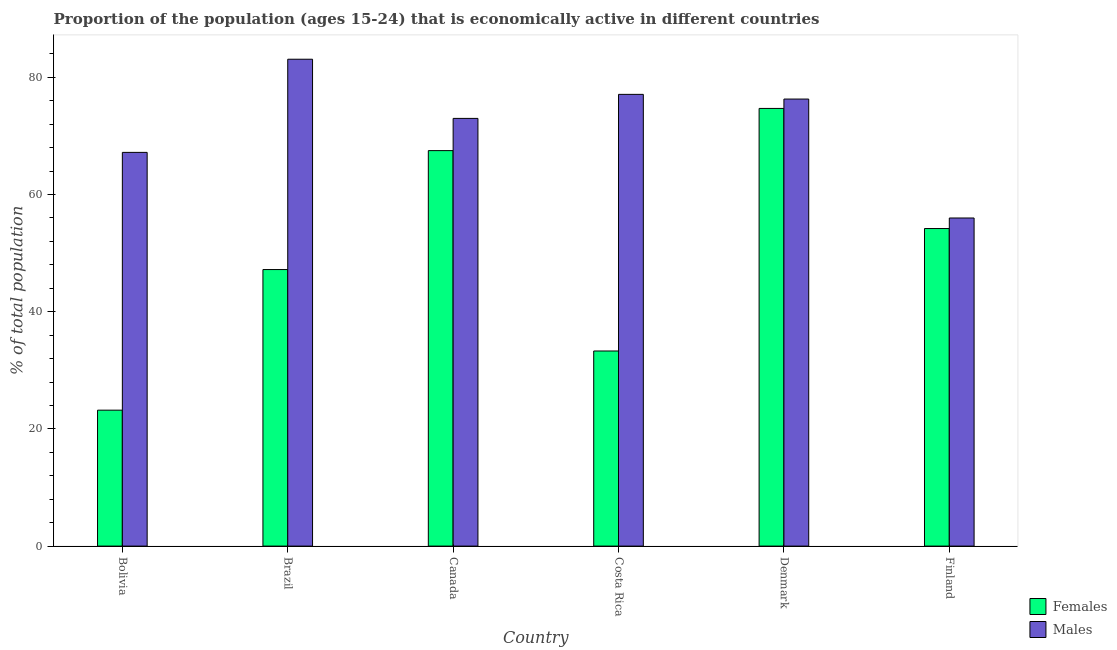How many different coloured bars are there?
Provide a succinct answer. 2. Are the number of bars on each tick of the X-axis equal?
Your response must be concise. Yes. How many bars are there on the 6th tick from the left?
Make the answer very short. 2. How many bars are there on the 3rd tick from the right?
Your answer should be very brief. 2. What is the label of the 1st group of bars from the left?
Give a very brief answer. Bolivia. What is the percentage of economically active male population in Brazil?
Make the answer very short. 83.1. Across all countries, what is the maximum percentage of economically active male population?
Give a very brief answer. 83.1. Across all countries, what is the minimum percentage of economically active female population?
Offer a terse response. 23.2. In which country was the percentage of economically active female population maximum?
Your answer should be compact. Denmark. What is the total percentage of economically active male population in the graph?
Your response must be concise. 432.7. What is the difference between the percentage of economically active female population in Canada and that in Finland?
Your answer should be compact. 13.3. What is the difference between the percentage of economically active female population in Canada and the percentage of economically active male population in Brazil?
Offer a very short reply. -15.6. What is the average percentage of economically active female population per country?
Your answer should be compact. 50.02. What is the ratio of the percentage of economically active male population in Bolivia to that in Costa Rica?
Keep it short and to the point. 0.87. Is the percentage of economically active male population in Brazil less than that in Finland?
Ensure brevity in your answer.  No. What is the difference between the highest and the second highest percentage of economically active male population?
Ensure brevity in your answer.  6. What is the difference between the highest and the lowest percentage of economically active female population?
Your answer should be compact. 51.5. In how many countries, is the percentage of economically active female population greater than the average percentage of economically active female population taken over all countries?
Provide a succinct answer. 3. Is the sum of the percentage of economically active female population in Bolivia and Canada greater than the maximum percentage of economically active male population across all countries?
Make the answer very short. Yes. What does the 1st bar from the left in Costa Rica represents?
Provide a short and direct response. Females. What does the 2nd bar from the right in Brazil represents?
Ensure brevity in your answer.  Females. Are all the bars in the graph horizontal?
Provide a succinct answer. No. How many countries are there in the graph?
Make the answer very short. 6. Does the graph contain any zero values?
Offer a very short reply. No. Does the graph contain grids?
Ensure brevity in your answer.  No. Where does the legend appear in the graph?
Give a very brief answer. Bottom right. What is the title of the graph?
Provide a succinct answer. Proportion of the population (ages 15-24) that is economically active in different countries. Does "Depositors" appear as one of the legend labels in the graph?
Provide a short and direct response. No. What is the label or title of the X-axis?
Keep it short and to the point. Country. What is the label or title of the Y-axis?
Provide a short and direct response. % of total population. What is the % of total population of Females in Bolivia?
Keep it short and to the point. 23.2. What is the % of total population of Males in Bolivia?
Ensure brevity in your answer.  67.2. What is the % of total population in Females in Brazil?
Offer a terse response. 47.2. What is the % of total population of Males in Brazil?
Your answer should be compact. 83.1. What is the % of total population of Females in Canada?
Make the answer very short. 67.5. What is the % of total population in Males in Canada?
Give a very brief answer. 73. What is the % of total population of Females in Costa Rica?
Ensure brevity in your answer.  33.3. What is the % of total population in Males in Costa Rica?
Give a very brief answer. 77.1. What is the % of total population in Females in Denmark?
Provide a short and direct response. 74.7. What is the % of total population of Males in Denmark?
Provide a short and direct response. 76.3. What is the % of total population of Females in Finland?
Your response must be concise. 54.2. What is the % of total population in Males in Finland?
Offer a terse response. 56. Across all countries, what is the maximum % of total population of Females?
Keep it short and to the point. 74.7. Across all countries, what is the maximum % of total population in Males?
Provide a succinct answer. 83.1. Across all countries, what is the minimum % of total population of Females?
Provide a short and direct response. 23.2. What is the total % of total population in Females in the graph?
Keep it short and to the point. 300.1. What is the total % of total population of Males in the graph?
Ensure brevity in your answer.  432.7. What is the difference between the % of total population of Males in Bolivia and that in Brazil?
Keep it short and to the point. -15.9. What is the difference between the % of total population of Females in Bolivia and that in Canada?
Offer a terse response. -44.3. What is the difference between the % of total population of Males in Bolivia and that in Costa Rica?
Your response must be concise. -9.9. What is the difference between the % of total population in Females in Bolivia and that in Denmark?
Your response must be concise. -51.5. What is the difference between the % of total population of Females in Bolivia and that in Finland?
Your answer should be very brief. -31. What is the difference between the % of total population of Males in Bolivia and that in Finland?
Make the answer very short. 11.2. What is the difference between the % of total population in Females in Brazil and that in Canada?
Your response must be concise. -20.3. What is the difference between the % of total population in Males in Brazil and that in Canada?
Your response must be concise. 10.1. What is the difference between the % of total population in Females in Brazil and that in Costa Rica?
Your answer should be very brief. 13.9. What is the difference between the % of total population of Females in Brazil and that in Denmark?
Offer a terse response. -27.5. What is the difference between the % of total population in Males in Brazil and that in Denmark?
Your answer should be compact. 6.8. What is the difference between the % of total population of Males in Brazil and that in Finland?
Provide a short and direct response. 27.1. What is the difference between the % of total population of Females in Canada and that in Costa Rica?
Provide a short and direct response. 34.2. What is the difference between the % of total population of Males in Canada and that in Costa Rica?
Ensure brevity in your answer.  -4.1. What is the difference between the % of total population of Females in Canada and that in Finland?
Make the answer very short. 13.3. What is the difference between the % of total population of Females in Costa Rica and that in Denmark?
Your response must be concise. -41.4. What is the difference between the % of total population of Males in Costa Rica and that in Denmark?
Provide a succinct answer. 0.8. What is the difference between the % of total population in Females in Costa Rica and that in Finland?
Make the answer very short. -20.9. What is the difference between the % of total population in Males in Costa Rica and that in Finland?
Give a very brief answer. 21.1. What is the difference between the % of total population in Females in Denmark and that in Finland?
Provide a short and direct response. 20.5. What is the difference between the % of total population in Males in Denmark and that in Finland?
Provide a succinct answer. 20.3. What is the difference between the % of total population of Females in Bolivia and the % of total population of Males in Brazil?
Make the answer very short. -59.9. What is the difference between the % of total population of Females in Bolivia and the % of total population of Males in Canada?
Ensure brevity in your answer.  -49.8. What is the difference between the % of total population of Females in Bolivia and the % of total population of Males in Costa Rica?
Provide a succinct answer. -53.9. What is the difference between the % of total population in Females in Bolivia and the % of total population in Males in Denmark?
Provide a succinct answer. -53.1. What is the difference between the % of total population of Females in Bolivia and the % of total population of Males in Finland?
Provide a succinct answer. -32.8. What is the difference between the % of total population in Females in Brazil and the % of total population in Males in Canada?
Ensure brevity in your answer.  -25.8. What is the difference between the % of total population in Females in Brazil and the % of total population in Males in Costa Rica?
Provide a succinct answer. -29.9. What is the difference between the % of total population in Females in Brazil and the % of total population in Males in Denmark?
Ensure brevity in your answer.  -29.1. What is the difference between the % of total population of Females in Brazil and the % of total population of Males in Finland?
Your answer should be very brief. -8.8. What is the difference between the % of total population of Females in Canada and the % of total population of Males in Denmark?
Provide a succinct answer. -8.8. What is the difference between the % of total population in Females in Canada and the % of total population in Males in Finland?
Ensure brevity in your answer.  11.5. What is the difference between the % of total population of Females in Costa Rica and the % of total population of Males in Denmark?
Provide a short and direct response. -43. What is the difference between the % of total population of Females in Costa Rica and the % of total population of Males in Finland?
Ensure brevity in your answer.  -22.7. What is the average % of total population in Females per country?
Offer a terse response. 50.02. What is the average % of total population of Males per country?
Your answer should be compact. 72.12. What is the difference between the % of total population in Females and % of total population in Males in Bolivia?
Your answer should be very brief. -44. What is the difference between the % of total population in Females and % of total population in Males in Brazil?
Your answer should be very brief. -35.9. What is the difference between the % of total population in Females and % of total population in Males in Costa Rica?
Ensure brevity in your answer.  -43.8. What is the difference between the % of total population of Females and % of total population of Males in Finland?
Your response must be concise. -1.8. What is the ratio of the % of total population in Females in Bolivia to that in Brazil?
Keep it short and to the point. 0.49. What is the ratio of the % of total population in Males in Bolivia to that in Brazil?
Your response must be concise. 0.81. What is the ratio of the % of total population of Females in Bolivia to that in Canada?
Your answer should be very brief. 0.34. What is the ratio of the % of total population of Males in Bolivia to that in Canada?
Your answer should be compact. 0.92. What is the ratio of the % of total population of Females in Bolivia to that in Costa Rica?
Make the answer very short. 0.7. What is the ratio of the % of total population of Males in Bolivia to that in Costa Rica?
Ensure brevity in your answer.  0.87. What is the ratio of the % of total population of Females in Bolivia to that in Denmark?
Your answer should be compact. 0.31. What is the ratio of the % of total population of Males in Bolivia to that in Denmark?
Your answer should be very brief. 0.88. What is the ratio of the % of total population in Females in Bolivia to that in Finland?
Offer a terse response. 0.43. What is the ratio of the % of total population of Females in Brazil to that in Canada?
Give a very brief answer. 0.7. What is the ratio of the % of total population in Males in Brazil to that in Canada?
Ensure brevity in your answer.  1.14. What is the ratio of the % of total population of Females in Brazil to that in Costa Rica?
Offer a very short reply. 1.42. What is the ratio of the % of total population in Males in Brazil to that in Costa Rica?
Make the answer very short. 1.08. What is the ratio of the % of total population in Females in Brazil to that in Denmark?
Ensure brevity in your answer.  0.63. What is the ratio of the % of total population of Males in Brazil to that in Denmark?
Your answer should be very brief. 1.09. What is the ratio of the % of total population of Females in Brazil to that in Finland?
Give a very brief answer. 0.87. What is the ratio of the % of total population of Males in Brazil to that in Finland?
Provide a short and direct response. 1.48. What is the ratio of the % of total population of Females in Canada to that in Costa Rica?
Your answer should be compact. 2.03. What is the ratio of the % of total population of Males in Canada to that in Costa Rica?
Offer a very short reply. 0.95. What is the ratio of the % of total population of Females in Canada to that in Denmark?
Give a very brief answer. 0.9. What is the ratio of the % of total population in Males in Canada to that in Denmark?
Ensure brevity in your answer.  0.96. What is the ratio of the % of total population in Females in Canada to that in Finland?
Your answer should be compact. 1.25. What is the ratio of the % of total population of Males in Canada to that in Finland?
Keep it short and to the point. 1.3. What is the ratio of the % of total population of Females in Costa Rica to that in Denmark?
Provide a short and direct response. 0.45. What is the ratio of the % of total population in Males in Costa Rica to that in Denmark?
Your response must be concise. 1.01. What is the ratio of the % of total population in Females in Costa Rica to that in Finland?
Give a very brief answer. 0.61. What is the ratio of the % of total population of Males in Costa Rica to that in Finland?
Keep it short and to the point. 1.38. What is the ratio of the % of total population in Females in Denmark to that in Finland?
Offer a very short reply. 1.38. What is the ratio of the % of total population in Males in Denmark to that in Finland?
Provide a short and direct response. 1.36. What is the difference between the highest and the second highest % of total population of Females?
Your response must be concise. 7.2. What is the difference between the highest and the second highest % of total population of Males?
Ensure brevity in your answer.  6. What is the difference between the highest and the lowest % of total population in Females?
Your response must be concise. 51.5. What is the difference between the highest and the lowest % of total population in Males?
Make the answer very short. 27.1. 